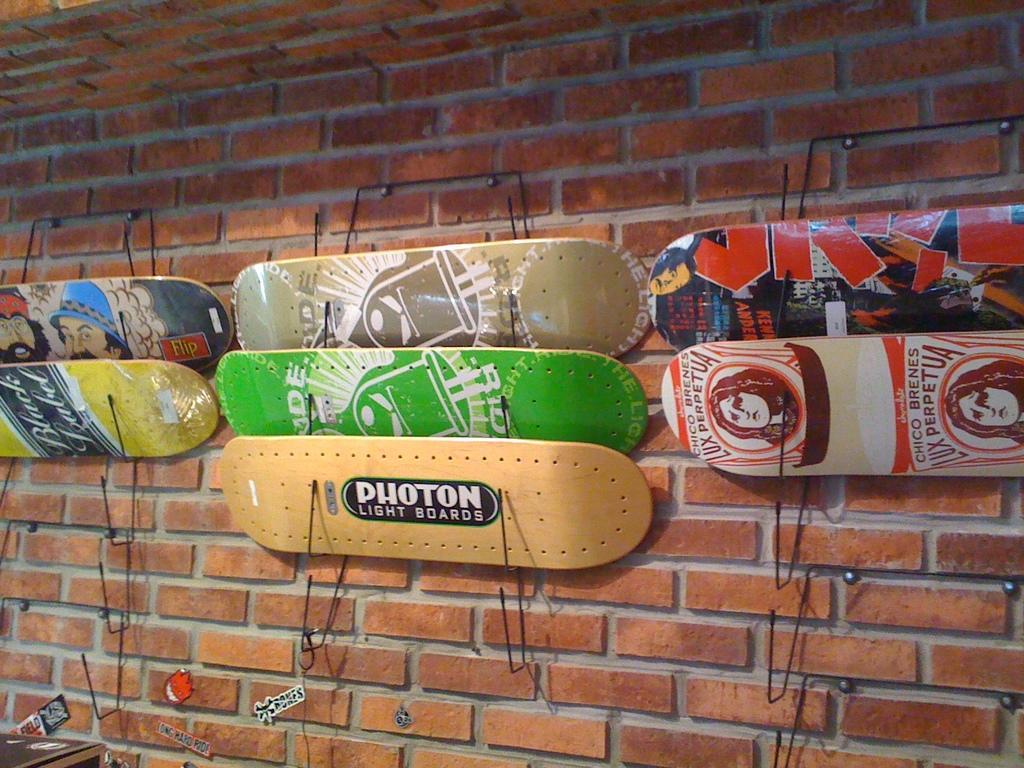In one or two sentences, can you explain what this image depicts? In this image, I can see boards on a wall and some objects. This image taken, maybe in a hall. 